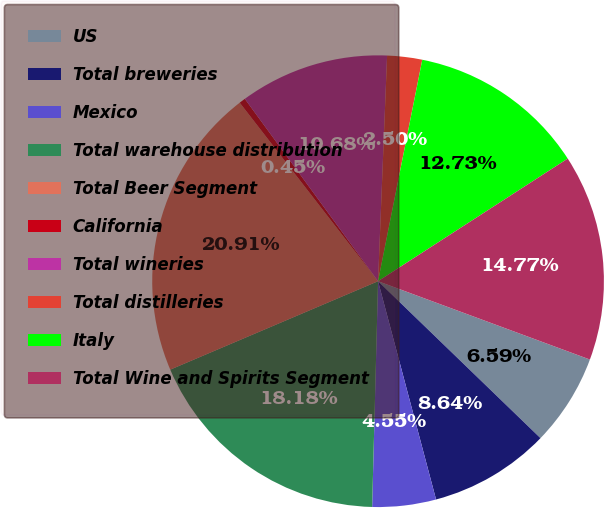Convert chart to OTSL. <chart><loc_0><loc_0><loc_500><loc_500><pie_chart><fcel>US<fcel>Total breweries<fcel>Mexico<fcel>Total warehouse distribution<fcel>Total Beer Segment<fcel>California<fcel>Total wineries<fcel>Total distilleries<fcel>Italy<fcel>Total Wine and Spirits Segment<nl><fcel>6.59%<fcel>8.64%<fcel>4.55%<fcel>18.18%<fcel>20.91%<fcel>0.45%<fcel>10.68%<fcel>2.5%<fcel>12.73%<fcel>14.77%<nl></chart> 